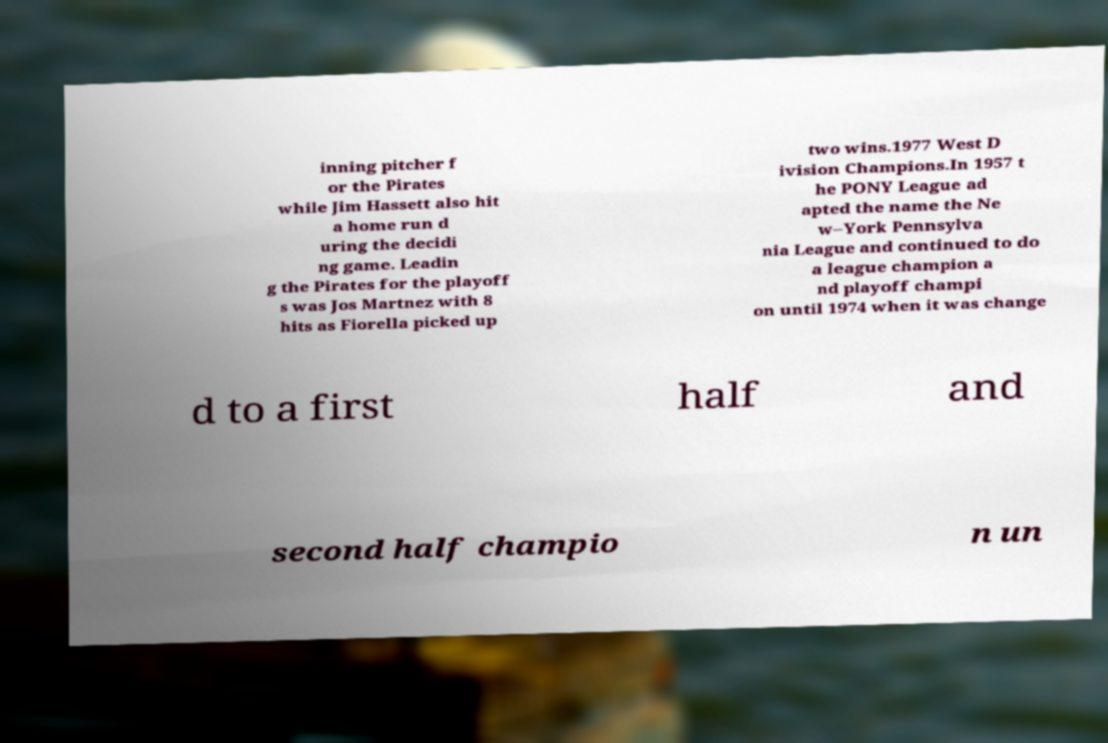Could you assist in decoding the text presented in this image and type it out clearly? inning pitcher f or the Pirates while Jim Hassett also hit a home run d uring the decidi ng game. Leadin g the Pirates for the playoff s was Jos Martnez with 8 hits as Fiorella picked up two wins.1977 West D ivision Champions.In 1957 t he PONY League ad apted the name the Ne w–York Pennsylva nia League and continued to do a league champion a nd playoff champi on until 1974 when it was change d to a first half and second half champio n un 